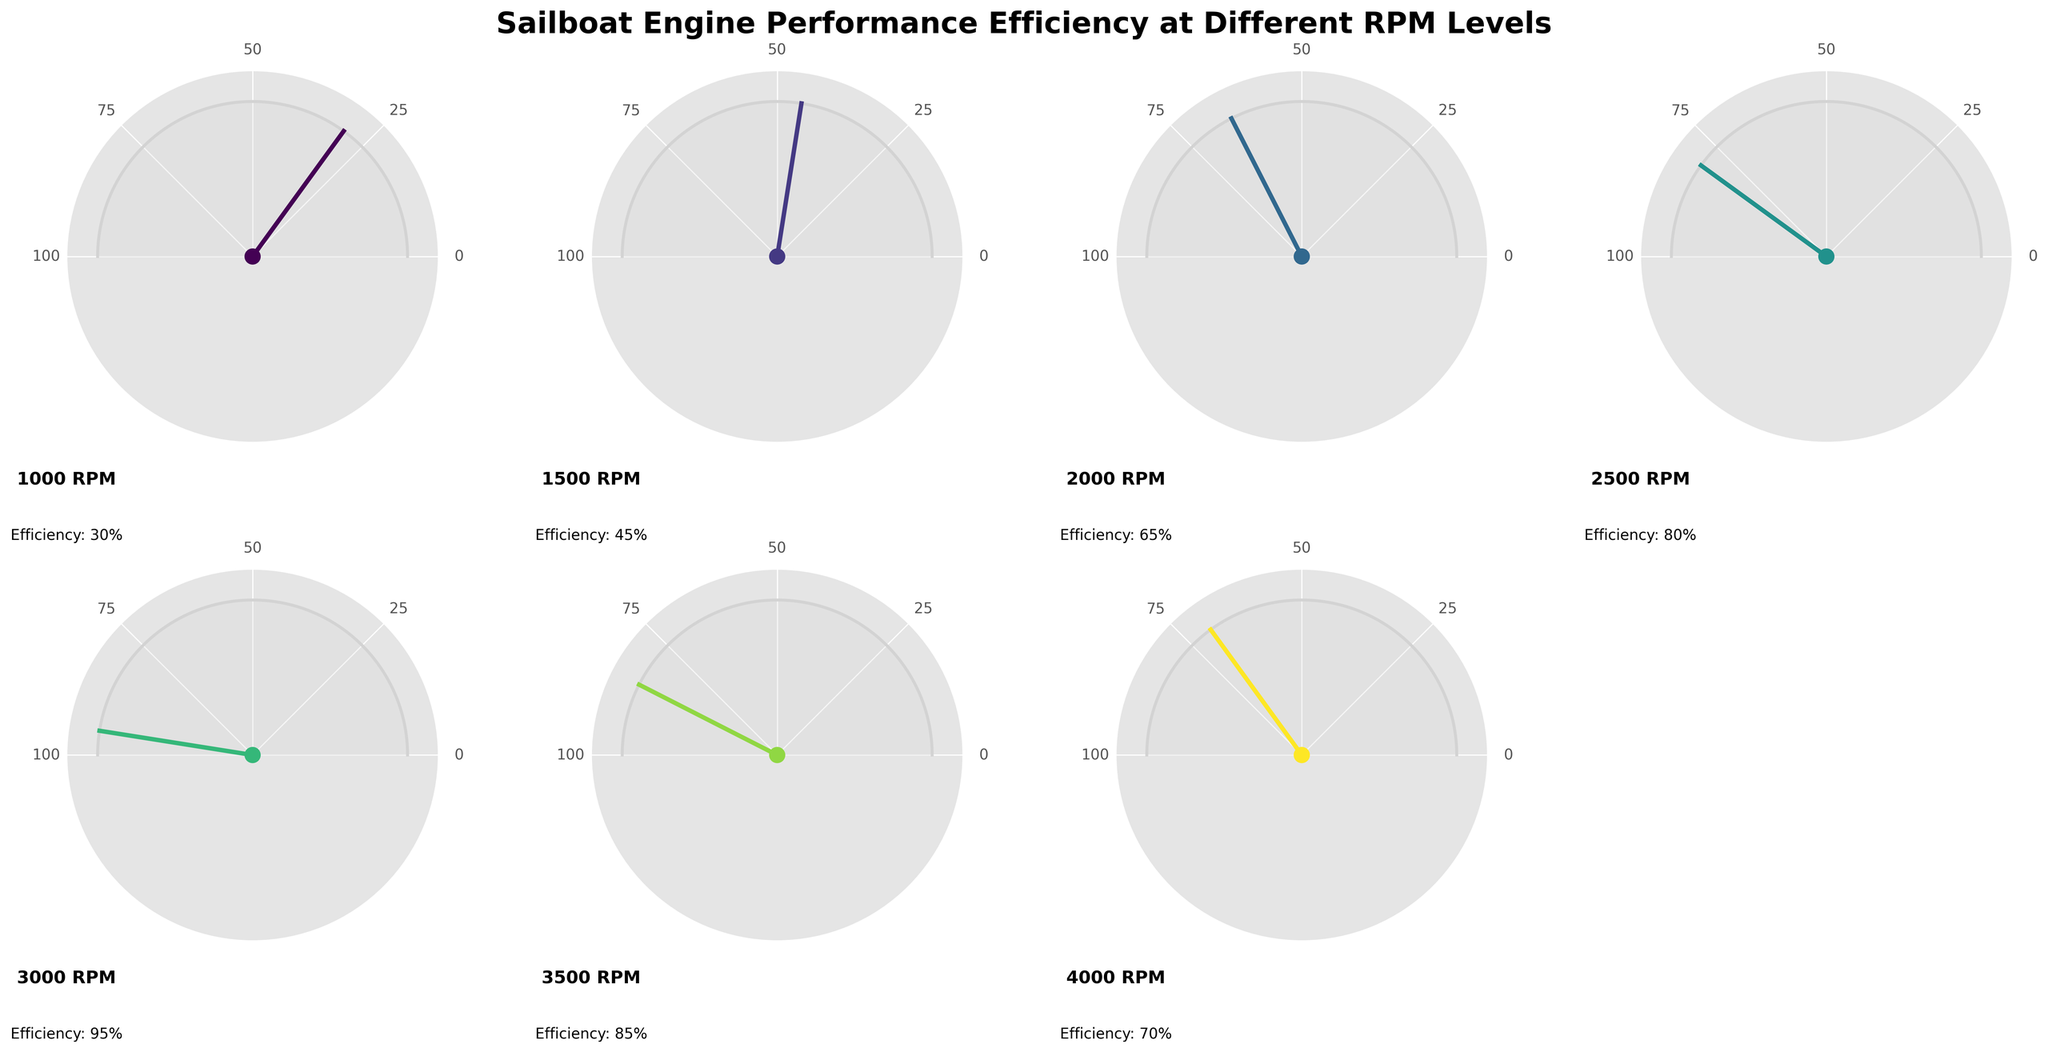what does the title of the figure say? The title is displayed prominently at the top of the figure. It describes the overall content of the figure. The title is "Sailboat Engine Performance Efficiency at Different RPM Levels."
Answer: Sailboat Engine Performance Efficiency at Different RPM Levels How many RPM levels are represented in the figure? Count the number of gauge charts displayed in the subplots. Each chart corresponds to an RPM level. There are seven gauge charts.
Answer: Seven Which RPM level shows the highest efficiency? Compare the efficiency percentages displayed at each RPM level. The highest efficiency percentage among them is 95%, which corresponds to the 3000 RPM level.
Answer: 3000 RPM Which RPM level has a lower efficiency, 3500 RPM or 4000 RPM? Compare the efficiency percentages shown for 3500 RPM and 4000 RPM. The efficiency at 3500 RPM is 85%, and at 4000 RPM, it is 70%. Since 85% is greater than 70%, 4000 RPM has lower efficiency.
Answer: 4000 RPM What is the average efficiency of the RPM levels shown? Add all the efficiency percentages and divide by the number of RPM levels: (30 + 45 + 65 + 80 + 95 + 85 + 70) / 7 = 470 / 7 = 67.14%
Answer: 67.14% At which RPM level(s) does the efficiency drop from the previous level? Compare the efficiency percentages between consecutive RPM levels. The efficiency drops from 95% at 3000 RPM to 85% at 3500 RPM, and from 85% at 3500 RPM to 70% at 4000 RPM.
Answer: 3500 RPM and 4000 RPM How much higher is the efficiency at 2000 RPM compared to 1000 RPM? Subtract the efficiency at 1000 RPM from the efficiency at 2000 RPM: 65% - 30% = 35%.
Answer: 35% What range of values do the RPM levels fall under according to the gauge charts? The RPM levels start from 1000 RPM and go up to 4000 RPM, in increments of 500 RPM.
Answer: 1000 RPM to 4000 RPM Which RPM levels have efficiencies above the overall average efficiency? The overall average efficiency is 67.14%. Compare this to the individual efficiencies: 1000 RPM (30%), 1500 RPM (45%), 2000 RPM (65%), 2500 RPM (80%), 3000 RPM (95%), 3500 RPM (85%), and 4000 RPM (70%). RPM levels 2500, 3000, 3500, and 4000 have efficiencies above 67.14%.
Answer: 2500 RPM, 3000 RPM, 3500 RPM, 4000 RPM What does the color of the efficiency indicator line represent in each gauge chart? The color of the efficiency indicator line varies based on the values. The color gradient is defined by the 'viridis' colormap, which is used to represent different efficiency values.
Answer: The efficiency level at a given RPM 